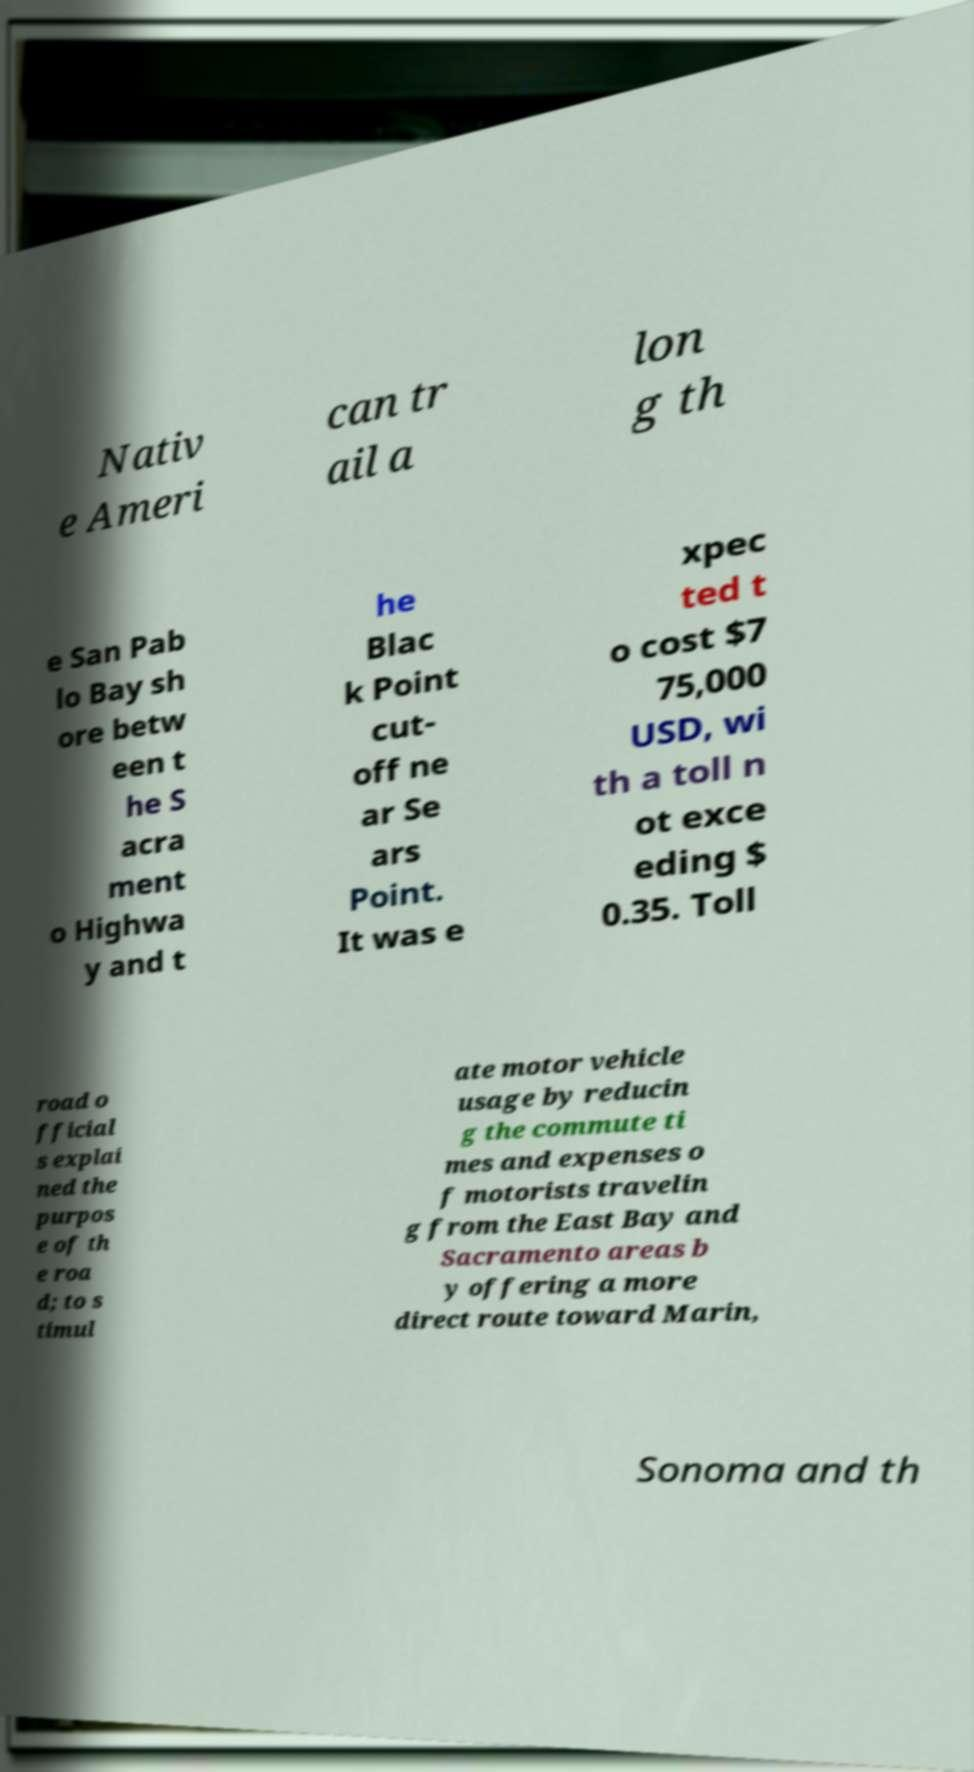Please read and relay the text visible in this image. What does it say? Nativ e Ameri can tr ail a lon g th e San Pab lo Bay sh ore betw een t he S acra ment o Highwa y and t he Blac k Point cut- off ne ar Se ars Point. It was e xpec ted t o cost $7 75,000 USD, wi th a toll n ot exce eding $ 0.35. Toll road o fficial s explai ned the purpos e of th e roa d; to s timul ate motor vehicle usage by reducin g the commute ti mes and expenses o f motorists travelin g from the East Bay and Sacramento areas b y offering a more direct route toward Marin, Sonoma and th 